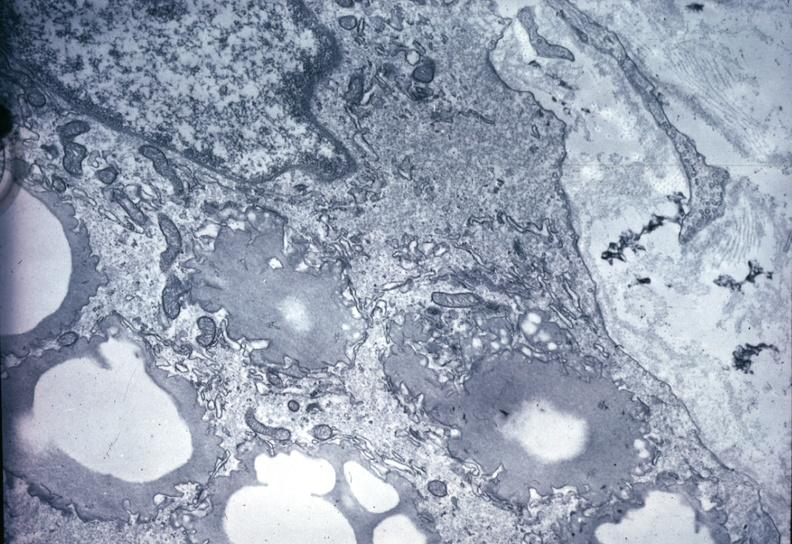s nodular tumor present?
Answer the question using a single word or phrase. No 